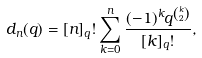<formula> <loc_0><loc_0><loc_500><loc_500>d _ { n } ( q ) = [ n ] _ { q } ! \sum _ { k = 0 } ^ { n } \frac { ( - 1 ) ^ { k } q ^ { k \choose 2 } } { [ k ] _ { q } ! } ,</formula> 